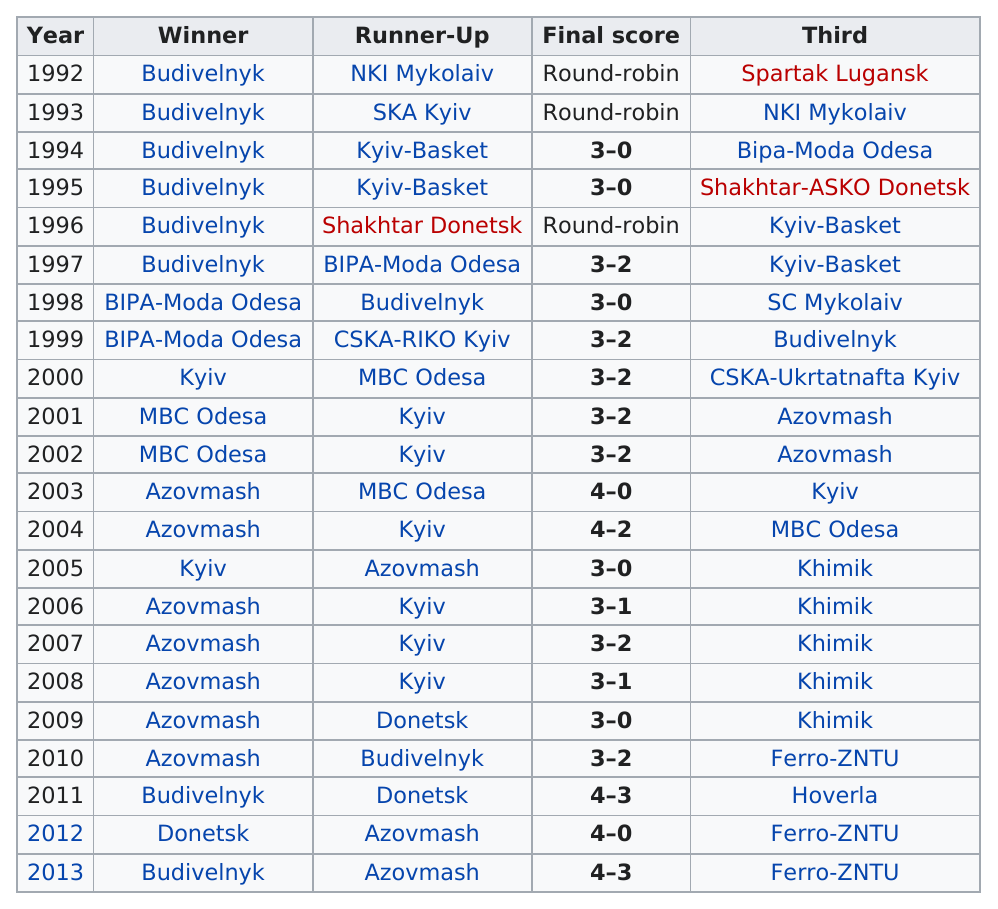Mention a couple of crucial points in this snapshot. In the first year of 1992, Budivelnyk was the winner. Budivelnyk has won the league the most out of all teams. The games occurred for 21 years from the first year listed to the last year listed. The average number of wins per year is 3. Donetsk was the only team to win the Ukrainian Basketball Super League championship once, making them the sole winner of the competition. 